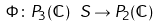<formula> <loc_0><loc_0><loc_500><loc_500>\Phi \colon P _ { 3 } ( \mathbb { C } ) \ S \rightarrow P _ { 2 } ( \mathbb { C } )</formula> 